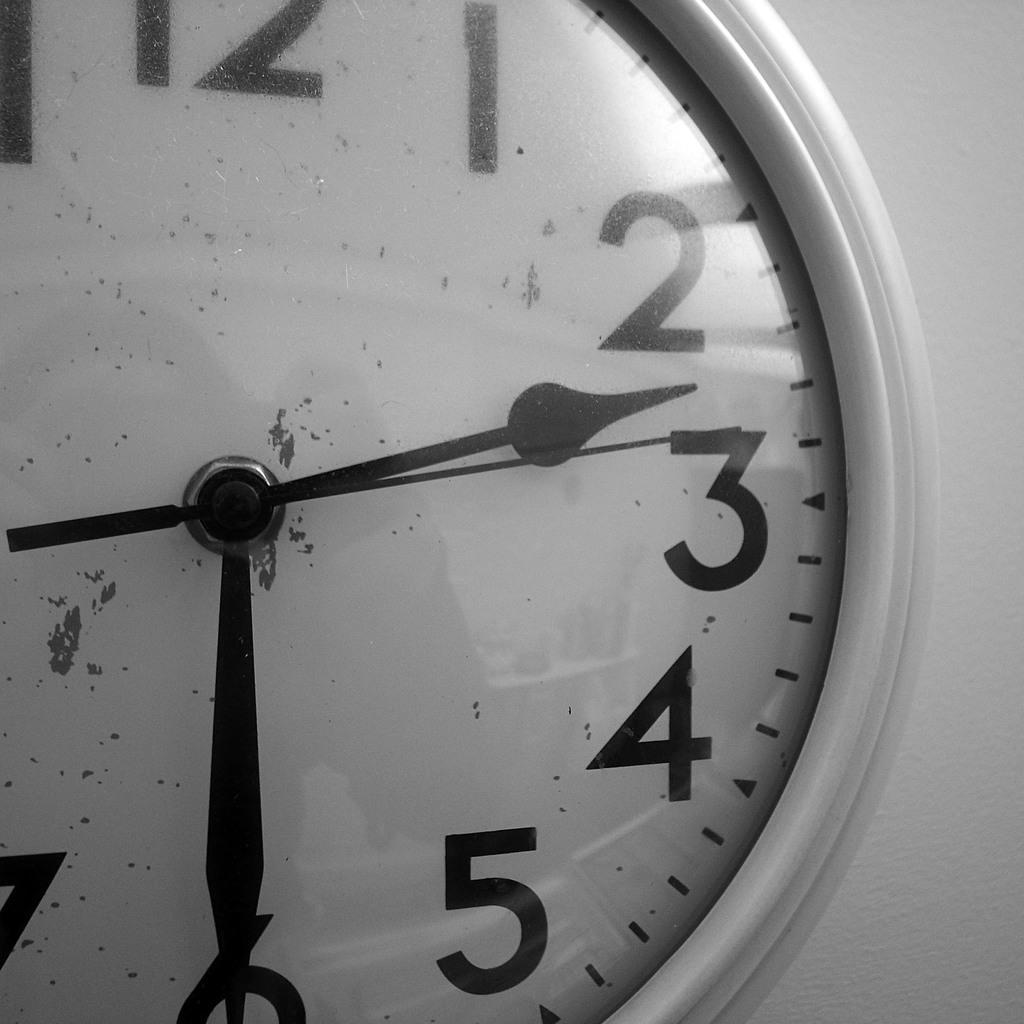In one or two sentences, can you explain what this image depicts? In this picture we can see a clock with numbers, hour hand, and minute hand and a second hand. 